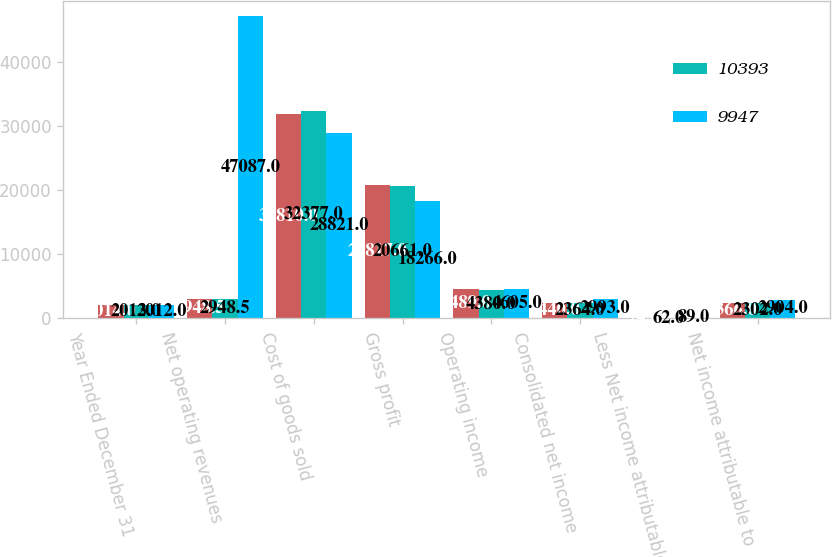Convert chart. <chart><loc_0><loc_0><loc_500><loc_500><stacked_bar_chart><ecel><fcel>Year Ended December 31<fcel>Net operating revenues<fcel>Cost of goods sold<fcel>Gross profit<fcel>Operating income<fcel>Consolidated net income<fcel>Less Net income attributable<fcel>Net income attributable to<nl><fcel>nan<fcel>2014<fcel>2948.5<fcel>31810<fcel>20817<fcel>4489<fcel>2440<fcel>74<fcel>2366<nl><fcel>10393<fcel>2013<fcel>2948.5<fcel>32377<fcel>20661<fcel>4380<fcel>2364<fcel>62<fcel>2302<nl><fcel>9947<fcel>2012<fcel>47087<fcel>28821<fcel>18266<fcel>4605<fcel>2993<fcel>89<fcel>2904<nl></chart> 